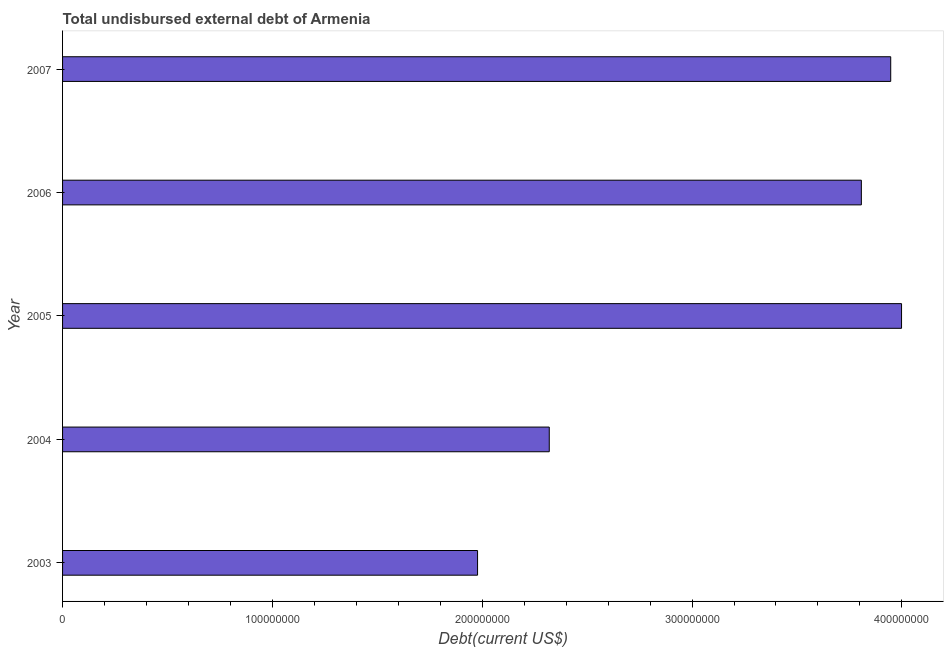What is the title of the graph?
Your answer should be compact. Total undisbursed external debt of Armenia. What is the label or title of the X-axis?
Ensure brevity in your answer.  Debt(current US$). What is the label or title of the Y-axis?
Make the answer very short. Year. What is the total debt in 2006?
Offer a terse response. 3.81e+08. Across all years, what is the maximum total debt?
Your answer should be compact. 4.00e+08. Across all years, what is the minimum total debt?
Provide a succinct answer. 1.98e+08. What is the sum of the total debt?
Your answer should be compact. 1.60e+09. What is the difference between the total debt in 2003 and 2007?
Provide a succinct answer. -1.97e+08. What is the average total debt per year?
Keep it short and to the point. 3.21e+08. What is the median total debt?
Offer a terse response. 3.81e+08. In how many years, is the total debt greater than 260000000 US$?
Provide a succinct answer. 3. What is the ratio of the total debt in 2006 to that in 2007?
Give a very brief answer. 0.96. What is the difference between the highest and the second highest total debt?
Provide a short and direct response. 5.16e+06. Is the sum of the total debt in 2005 and 2006 greater than the maximum total debt across all years?
Keep it short and to the point. Yes. What is the difference between the highest and the lowest total debt?
Your answer should be compact. 2.02e+08. In how many years, is the total debt greater than the average total debt taken over all years?
Your response must be concise. 3. How many bars are there?
Provide a succinct answer. 5. How many years are there in the graph?
Give a very brief answer. 5. What is the difference between two consecutive major ticks on the X-axis?
Offer a very short reply. 1.00e+08. What is the Debt(current US$) in 2003?
Your response must be concise. 1.98e+08. What is the Debt(current US$) of 2004?
Keep it short and to the point. 2.32e+08. What is the Debt(current US$) in 2005?
Your response must be concise. 4.00e+08. What is the Debt(current US$) in 2006?
Offer a very short reply. 3.81e+08. What is the Debt(current US$) in 2007?
Your answer should be very brief. 3.95e+08. What is the difference between the Debt(current US$) in 2003 and 2004?
Give a very brief answer. -3.42e+07. What is the difference between the Debt(current US$) in 2003 and 2005?
Offer a very short reply. -2.02e+08. What is the difference between the Debt(current US$) in 2003 and 2006?
Keep it short and to the point. -1.83e+08. What is the difference between the Debt(current US$) in 2003 and 2007?
Your response must be concise. -1.97e+08. What is the difference between the Debt(current US$) in 2004 and 2005?
Ensure brevity in your answer.  -1.68e+08. What is the difference between the Debt(current US$) in 2004 and 2006?
Make the answer very short. -1.49e+08. What is the difference between the Debt(current US$) in 2004 and 2007?
Make the answer very short. -1.63e+08. What is the difference between the Debt(current US$) in 2005 and 2006?
Ensure brevity in your answer.  1.92e+07. What is the difference between the Debt(current US$) in 2005 and 2007?
Offer a very short reply. 5.16e+06. What is the difference between the Debt(current US$) in 2006 and 2007?
Ensure brevity in your answer.  -1.40e+07. What is the ratio of the Debt(current US$) in 2003 to that in 2004?
Make the answer very short. 0.85. What is the ratio of the Debt(current US$) in 2003 to that in 2005?
Your response must be concise. 0.49. What is the ratio of the Debt(current US$) in 2003 to that in 2006?
Make the answer very short. 0.52. What is the ratio of the Debt(current US$) in 2003 to that in 2007?
Provide a succinct answer. 0.5. What is the ratio of the Debt(current US$) in 2004 to that in 2005?
Ensure brevity in your answer.  0.58. What is the ratio of the Debt(current US$) in 2004 to that in 2006?
Offer a terse response. 0.61. What is the ratio of the Debt(current US$) in 2004 to that in 2007?
Your response must be concise. 0.59. What is the ratio of the Debt(current US$) in 2006 to that in 2007?
Your response must be concise. 0.96. 